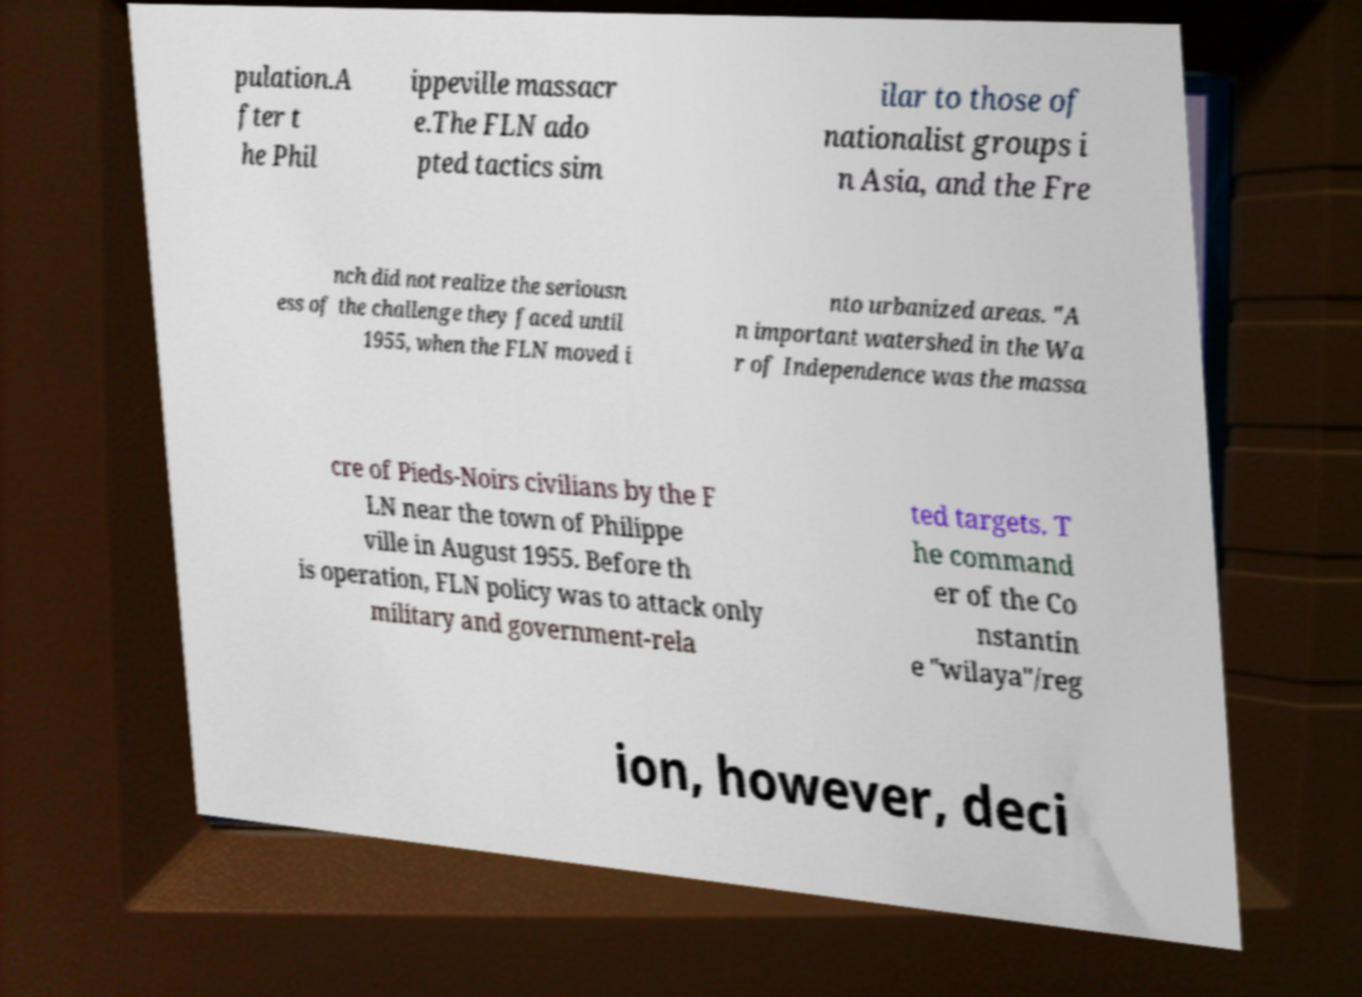Could you assist in decoding the text presented in this image and type it out clearly? pulation.A fter t he Phil ippeville massacr e.The FLN ado pted tactics sim ilar to those of nationalist groups i n Asia, and the Fre nch did not realize the seriousn ess of the challenge they faced until 1955, when the FLN moved i nto urbanized areas. "A n important watershed in the Wa r of Independence was the massa cre of Pieds-Noirs civilians by the F LN near the town of Philippe ville in August 1955. Before th is operation, FLN policy was to attack only military and government-rela ted targets. T he command er of the Co nstantin e "wilaya"/reg ion, however, deci 